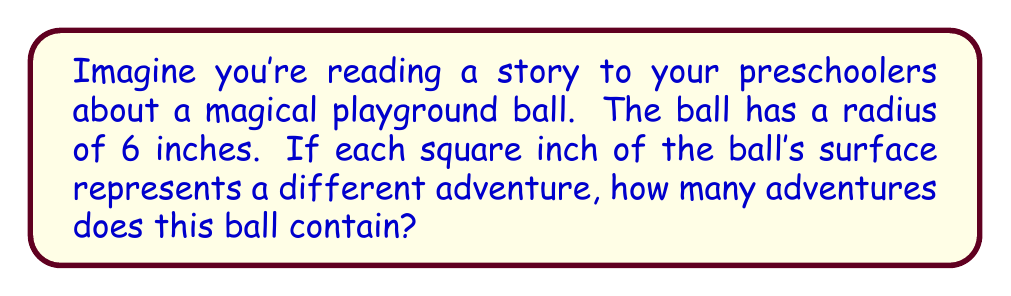Teach me how to tackle this problem. Let's approach this step-by-step:

1) The surface area of a sphere is given by the formula:
   $$A = 4\pi r^2$$
   Where $A$ is the surface area and $r$ is the radius.

2) We're told that the radius is 6 inches. Let's substitute this into our formula:
   $$A = 4\pi (6^2)$$

3) Let's simplify the expression inside the parentheses:
   $$A = 4\pi (36)$$

4) Now we can multiply:
   $$A = 144\pi$$

5) If we wanted to calculate this exactly, we'd leave it as $144\pi$. But since we're counting adventures, we need a whole number. Let's use 3.14 as an approximation for $\pi$:
   $$A \approx 144 * 3.14 = 452.16$$

6) Since we can't have a fraction of an adventure, we'll round down to the nearest whole number:
   $$A \approx 452\text{ square inches}$$

Therefore, the magical ball contains approximately 452 adventures!
Answer: 452 adventures 